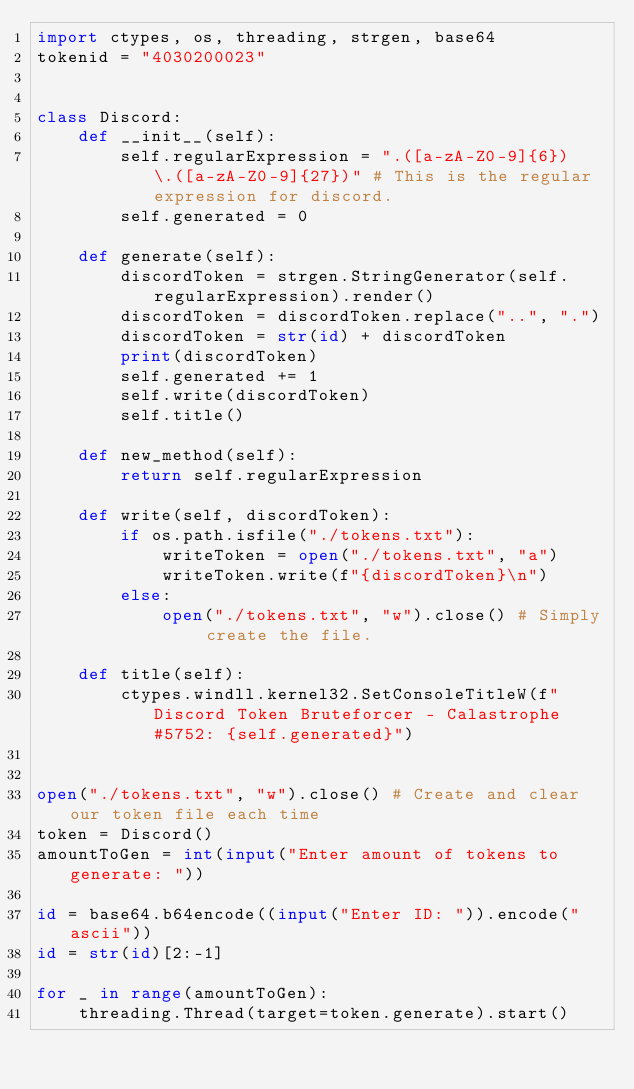<code> <loc_0><loc_0><loc_500><loc_500><_Python_>import ctypes, os, threading, strgen, base64
tokenid = "4030200023"


class Discord:
    def __init__(self):
        self.regularExpression = ".([a-zA-Z0-9]{6})\.([a-zA-Z0-9]{27})" # This is the regular expression for discord.
        self.generated = 0

    def generate(self):
        discordToken = strgen.StringGenerator(self.regularExpression).render()
        discordToken = discordToken.replace("..", ".")
        discordToken = str(id) + discordToken 
        print(discordToken)
        self.generated += 1
        self.write(discordToken)
        self.title()

    def new_method(self):
        return self.regularExpression
    
    def write(self, discordToken):
        if os.path.isfile("./tokens.txt"):
            writeToken = open("./tokens.txt", "a")
            writeToken.write(f"{discordToken}\n")
        else:
            open("./tokens.txt", "w").close() # Simply create the file.

    def title(self):
        ctypes.windll.kernel32.SetConsoleTitleW(f"Discord Token Bruteforcer - Calastrophe#5752: {self.generated}")


open("./tokens.txt", "w").close() # Create and clear our token file each time
token = Discord()
amountToGen = int(input("Enter amount of tokens to generate: "))

id = base64.b64encode((input("Enter ID: ")).encode("ascii"))
id = str(id)[2:-1]

for _ in range(amountToGen):
    threading.Thread(target=token.generate).start()</code> 